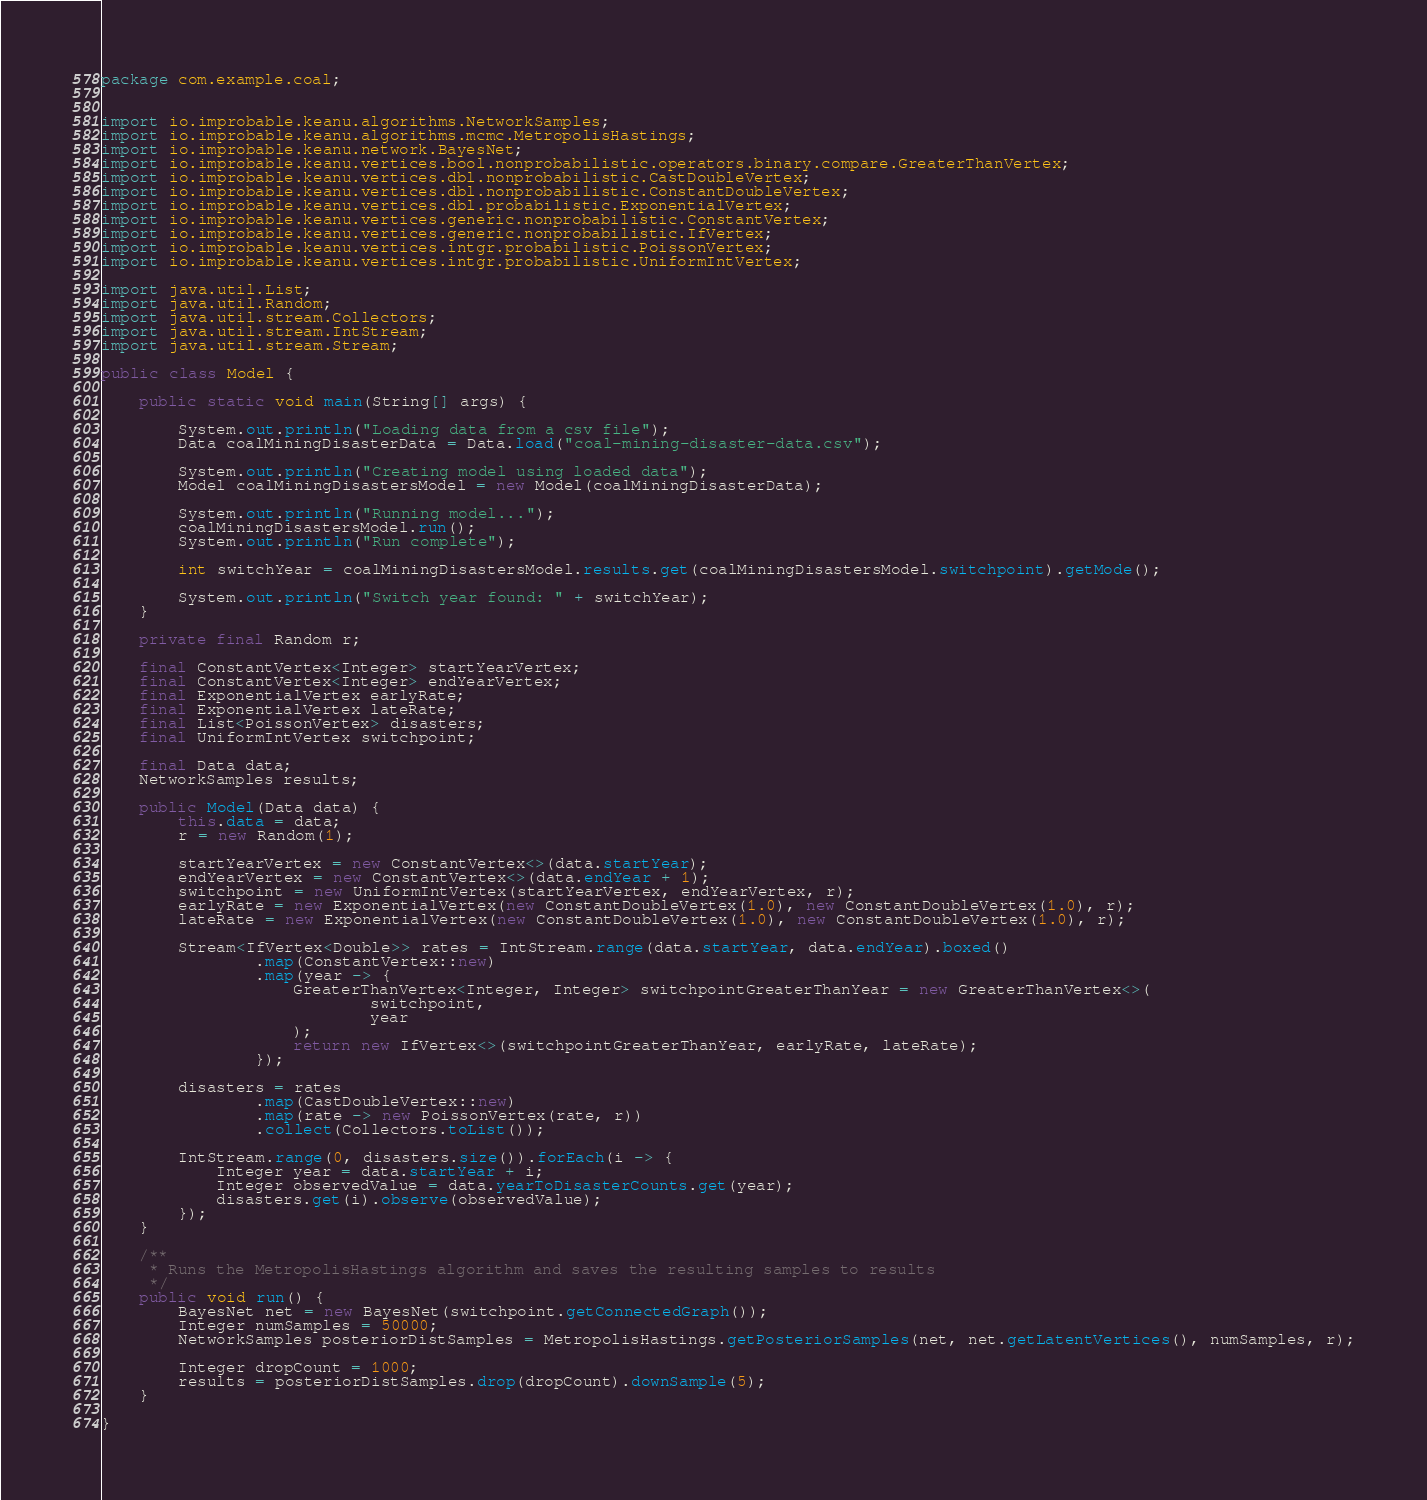<code> <loc_0><loc_0><loc_500><loc_500><_Java_>package com.example.coal;


import io.improbable.keanu.algorithms.NetworkSamples;
import io.improbable.keanu.algorithms.mcmc.MetropolisHastings;
import io.improbable.keanu.network.BayesNet;
import io.improbable.keanu.vertices.bool.nonprobabilistic.operators.binary.compare.GreaterThanVertex;
import io.improbable.keanu.vertices.dbl.nonprobabilistic.CastDoubleVertex;
import io.improbable.keanu.vertices.dbl.nonprobabilistic.ConstantDoubleVertex;
import io.improbable.keanu.vertices.dbl.probabilistic.ExponentialVertex;
import io.improbable.keanu.vertices.generic.nonprobabilistic.ConstantVertex;
import io.improbable.keanu.vertices.generic.nonprobabilistic.IfVertex;
import io.improbable.keanu.vertices.intgr.probabilistic.PoissonVertex;
import io.improbable.keanu.vertices.intgr.probabilistic.UniformIntVertex;

import java.util.List;
import java.util.Random;
import java.util.stream.Collectors;
import java.util.stream.IntStream;
import java.util.stream.Stream;

public class Model {

    public static void main(String[] args) {

        System.out.println("Loading data from a csv file");
        Data coalMiningDisasterData = Data.load("coal-mining-disaster-data.csv");

        System.out.println("Creating model using loaded data");
        Model coalMiningDisastersModel = new Model(coalMiningDisasterData);

        System.out.println("Running model...");
        coalMiningDisastersModel.run();
        System.out.println("Run complete");

        int switchYear = coalMiningDisastersModel.results.get(coalMiningDisastersModel.switchpoint).getMode();

        System.out.println("Switch year found: " + switchYear);
    }

    private final Random r;

    final ConstantVertex<Integer> startYearVertex;
    final ConstantVertex<Integer> endYearVertex;
    final ExponentialVertex earlyRate;
    final ExponentialVertex lateRate;
    final List<PoissonVertex> disasters;
    final UniformIntVertex switchpoint;

    final Data data;
    NetworkSamples results;

    public Model(Data data) {
        this.data = data;
        r = new Random(1);

        startYearVertex = new ConstantVertex<>(data.startYear);
        endYearVertex = new ConstantVertex<>(data.endYear + 1);
        switchpoint = new UniformIntVertex(startYearVertex, endYearVertex, r);
        earlyRate = new ExponentialVertex(new ConstantDoubleVertex(1.0), new ConstantDoubleVertex(1.0), r);
        lateRate = new ExponentialVertex(new ConstantDoubleVertex(1.0), new ConstantDoubleVertex(1.0), r);

        Stream<IfVertex<Double>> rates = IntStream.range(data.startYear, data.endYear).boxed()
                .map(ConstantVertex::new)
                .map(year -> {
                    GreaterThanVertex<Integer, Integer> switchpointGreaterThanYear = new GreaterThanVertex<>(
                            switchpoint,
                            year
                    );
                    return new IfVertex<>(switchpointGreaterThanYear, earlyRate, lateRate);
                });

        disasters = rates
                .map(CastDoubleVertex::new)
                .map(rate -> new PoissonVertex(rate, r))
                .collect(Collectors.toList());

        IntStream.range(0, disasters.size()).forEach(i -> {
            Integer year = data.startYear + i;
            Integer observedValue = data.yearToDisasterCounts.get(year);
            disasters.get(i).observe(observedValue);
        });
    }

    /**
     * Runs the MetropolisHastings algorithm and saves the resulting samples to results
     */
    public void run() {
        BayesNet net = new BayesNet(switchpoint.getConnectedGraph());
        Integer numSamples = 50000;
        NetworkSamples posteriorDistSamples = MetropolisHastings.getPosteriorSamples(net, net.getLatentVertices(), numSamples, r);

        Integer dropCount = 1000;
        results = posteriorDistSamples.drop(dropCount).downSample(5);
    }

}
</code> 